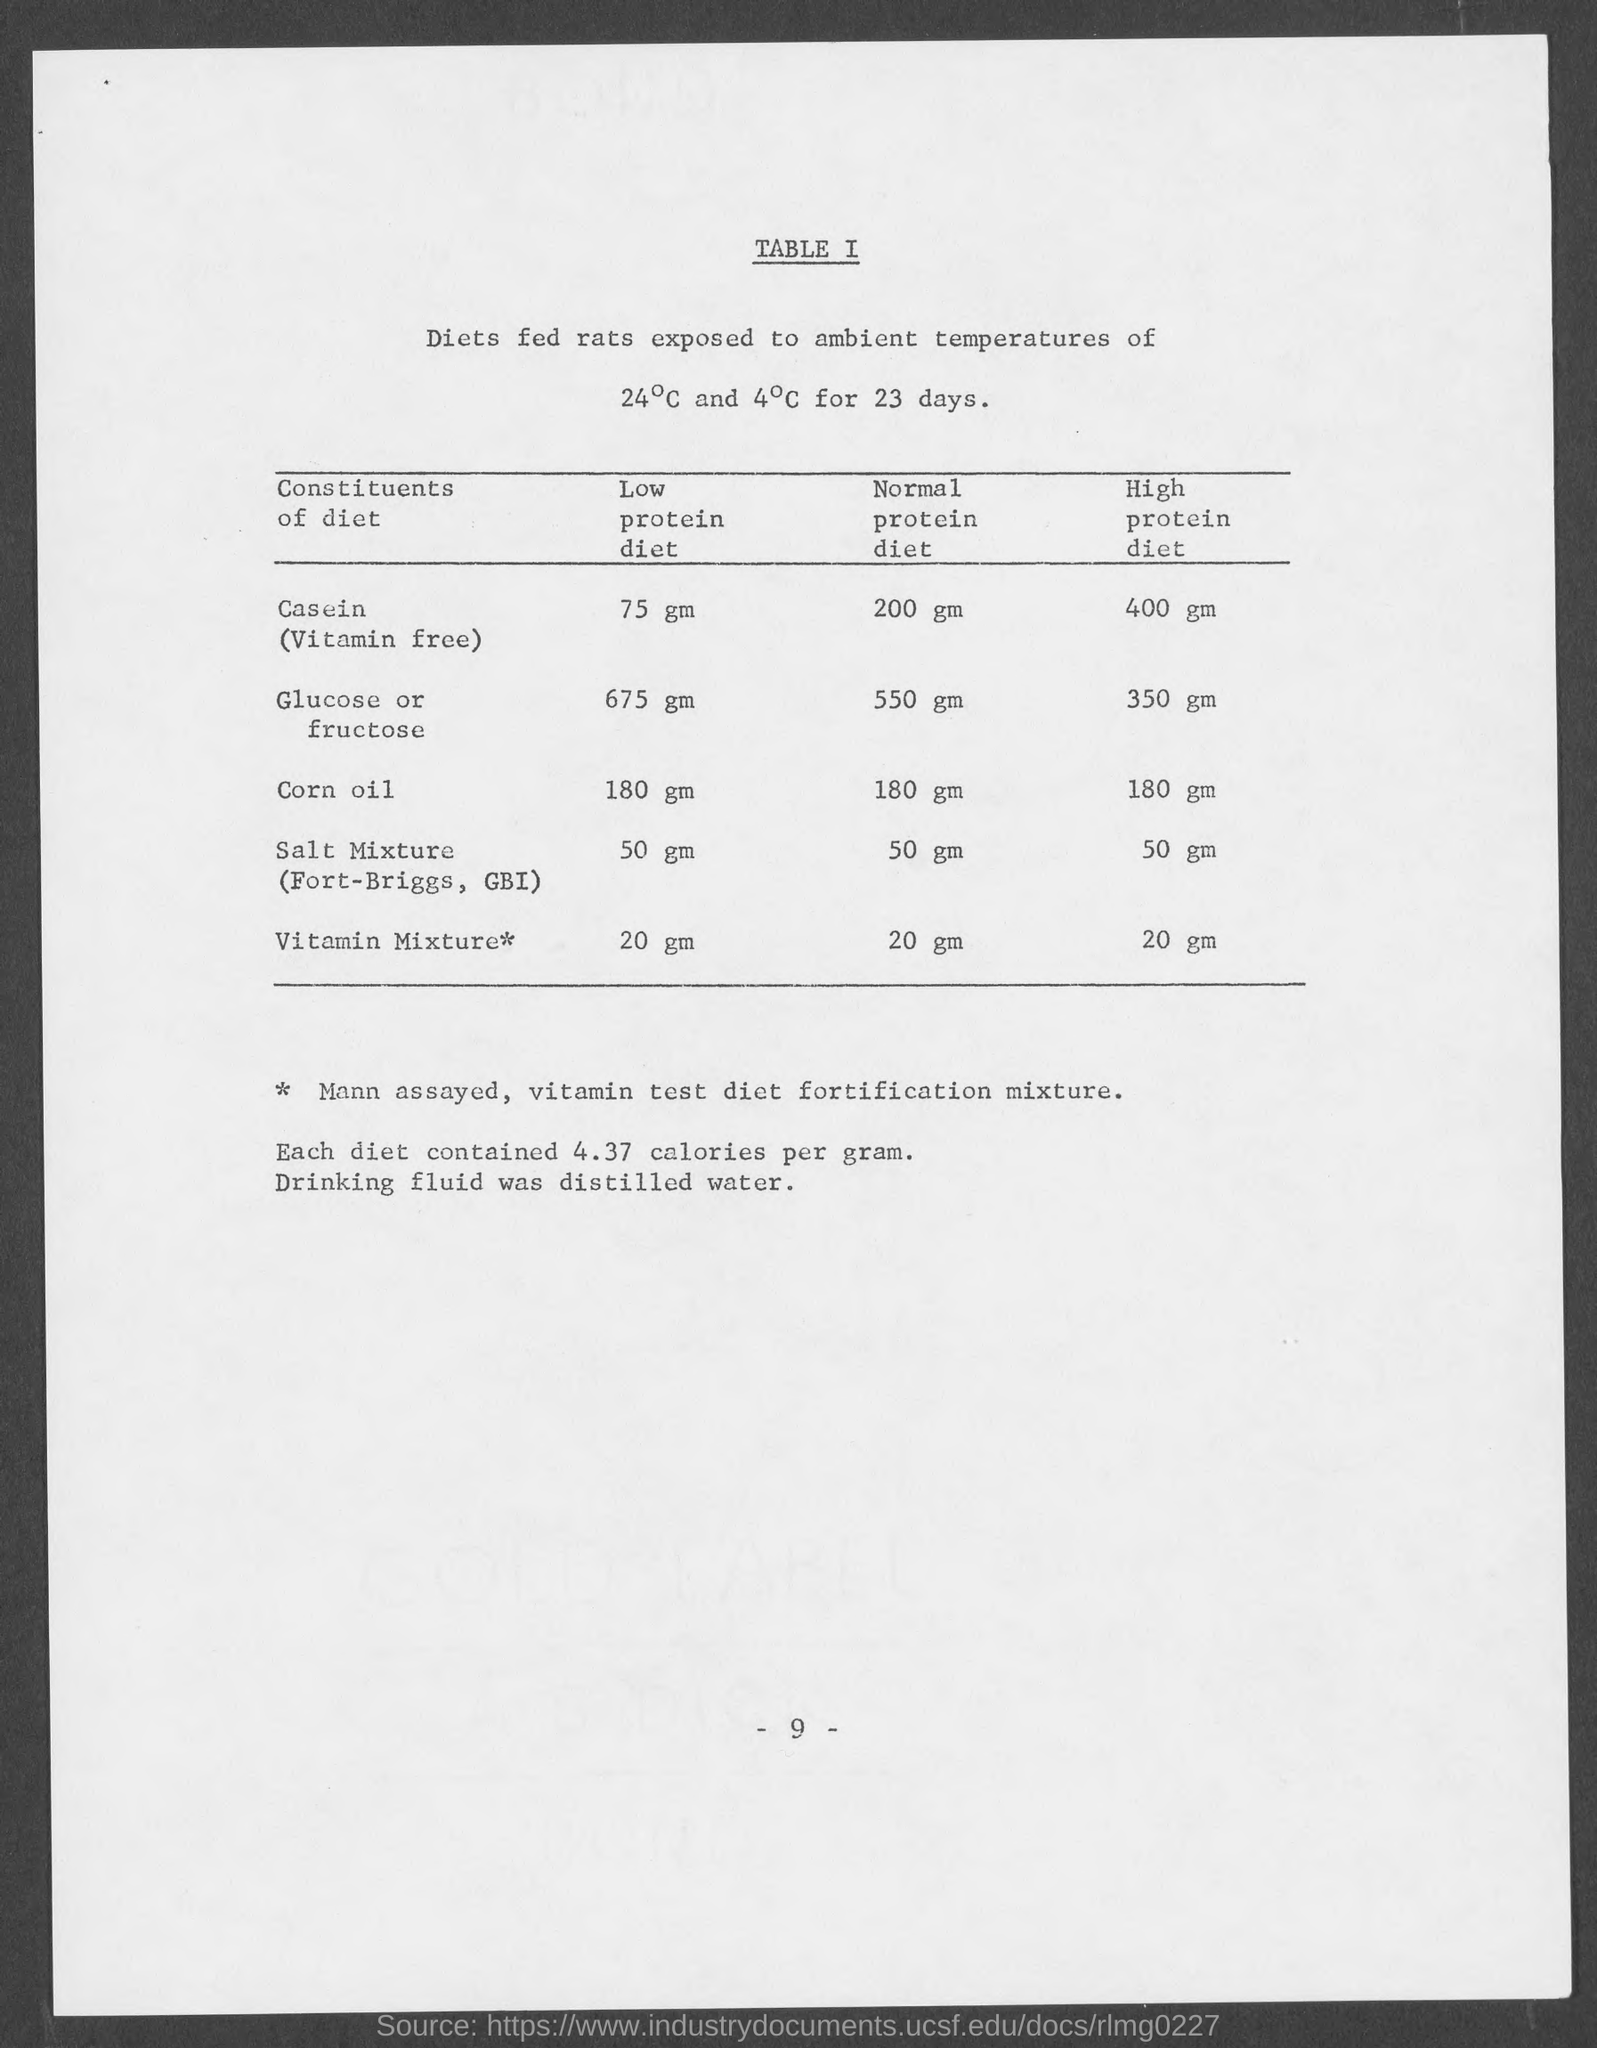Indicate a few pertinent items in this graphic. The page number at the bottom of the page is -9. 